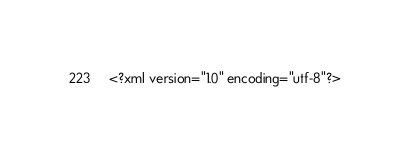<code> <loc_0><loc_0><loc_500><loc_500><_XML_><?xml version="1.0" encoding="utf-8"?></code> 